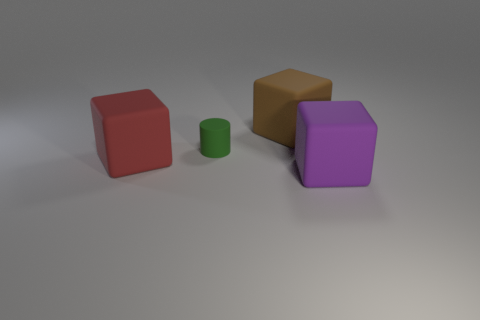Add 3 large purple matte cubes. How many objects exist? 7 Subtract all cylinders. How many objects are left? 3 Subtract 1 green cylinders. How many objects are left? 3 Subtract all big blue rubber things. Subtract all red things. How many objects are left? 3 Add 2 tiny green things. How many tiny green things are left? 3 Add 2 purple matte blocks. How many purple matte blocks exist? 3 